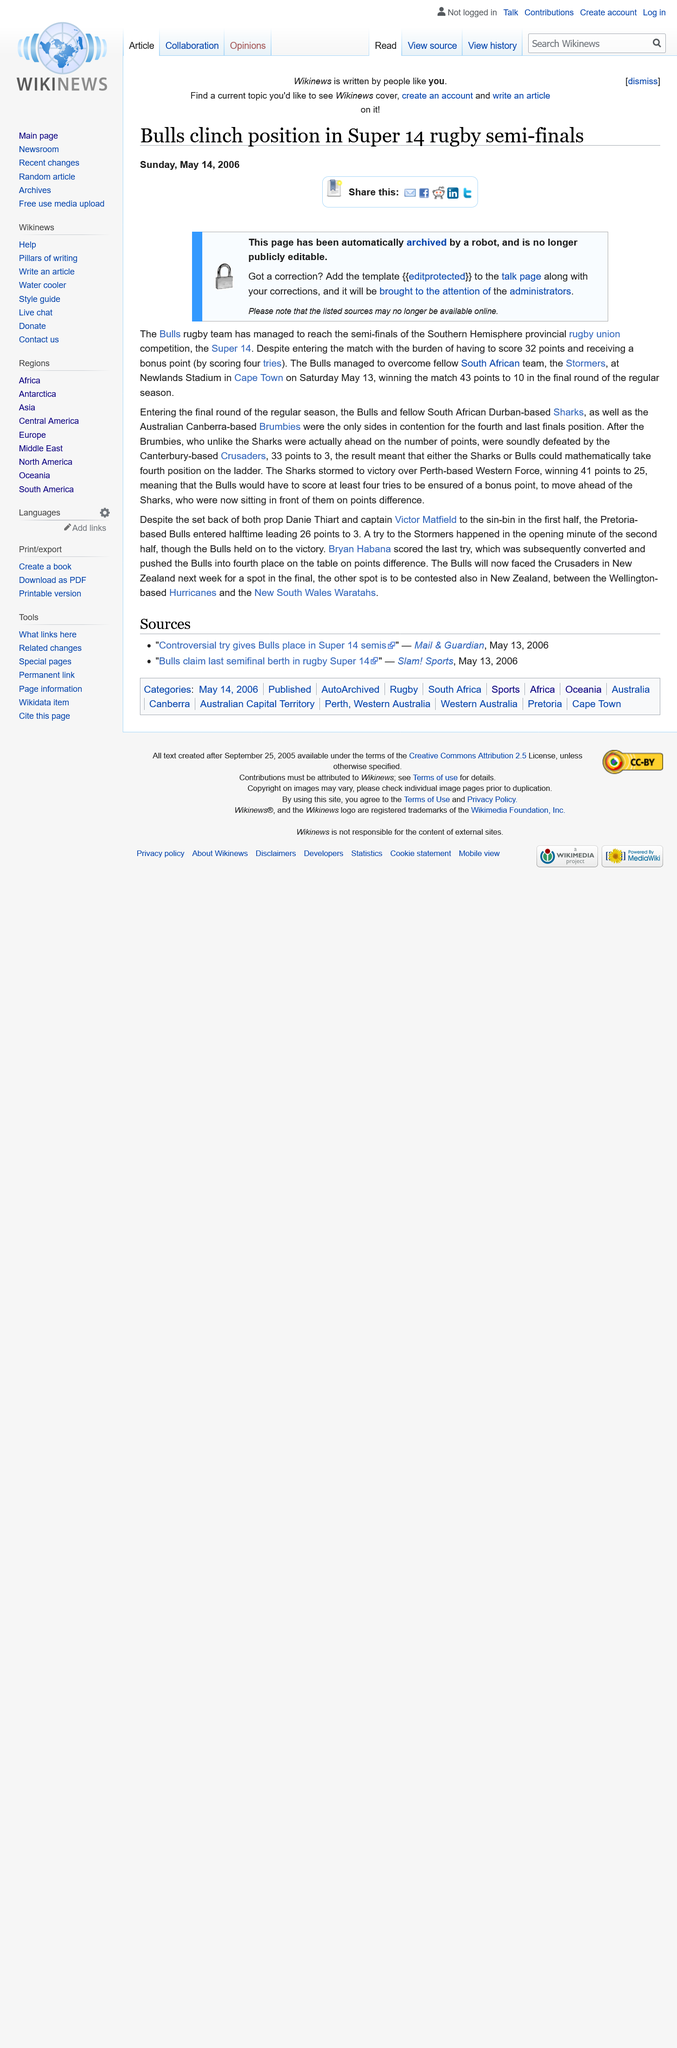Indicate a few pertinent items in this graphic. The match between the Bulls and the Stormers was held at Newlands Stadium in Cape Town on April 23, 2023. The report regarding the Bulls rugby team reaching the semi-finals of the Super 14, dated Sunday, May 14, 2006, is the date of the report. The Bulls faced off against the Stormers in the semi-final of the Super 14 tournament. 